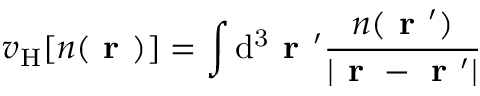Convert formula to latex. <formula><loc_0><loc_0><loc_500><loc_500>v _ { H } [ n ( r ) ] = \int d ^ { 3 } r ^ { \prime } \frac { n ( r ^ { \prime } ) } { | r - r ^ { \prime } | }</formula> 